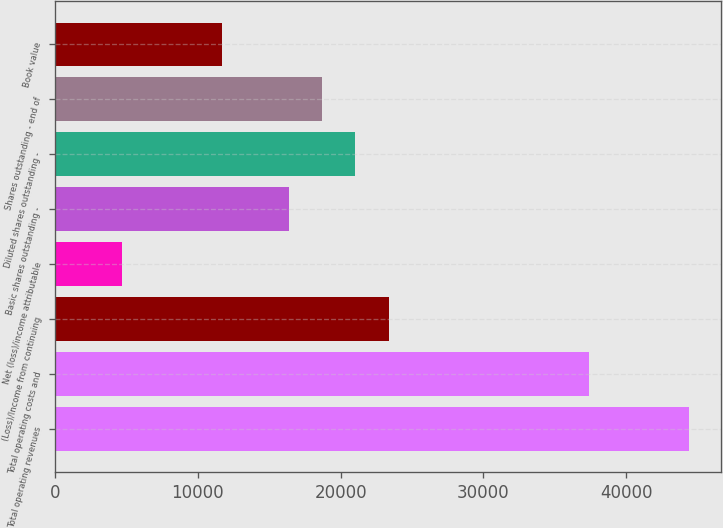Convert chart. <chart><loc_0><loc_0><loc_500><loc_500><bar_chart><fcel>Total operating revenues<fcel>Total operating costs and<fcel>(Loss)/Income from continuing<fcel>Net (loss)/income attributable<fcel>Basic shares outstanding -<fcel>Diluted shares outstanding -<fcel>Shares outstanding - end of<fcel>Book value<nl><fcel>44415.5<fcel>37403<fcel>23378<fcel>4678.04<fcel>16365.5<fcel>21040.5<fcel>18703<fcel>11690.5<nl></chart> 